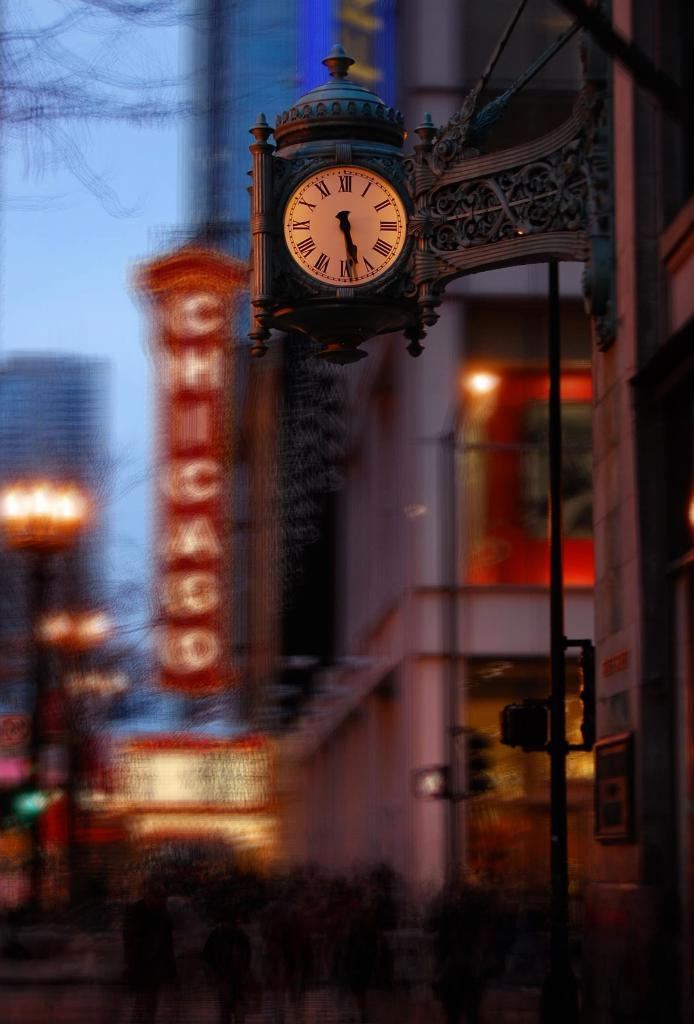<image>
Give a short and clear explanation of the subsequent image. A city street scene with a  blurred sign reading Chicago. 